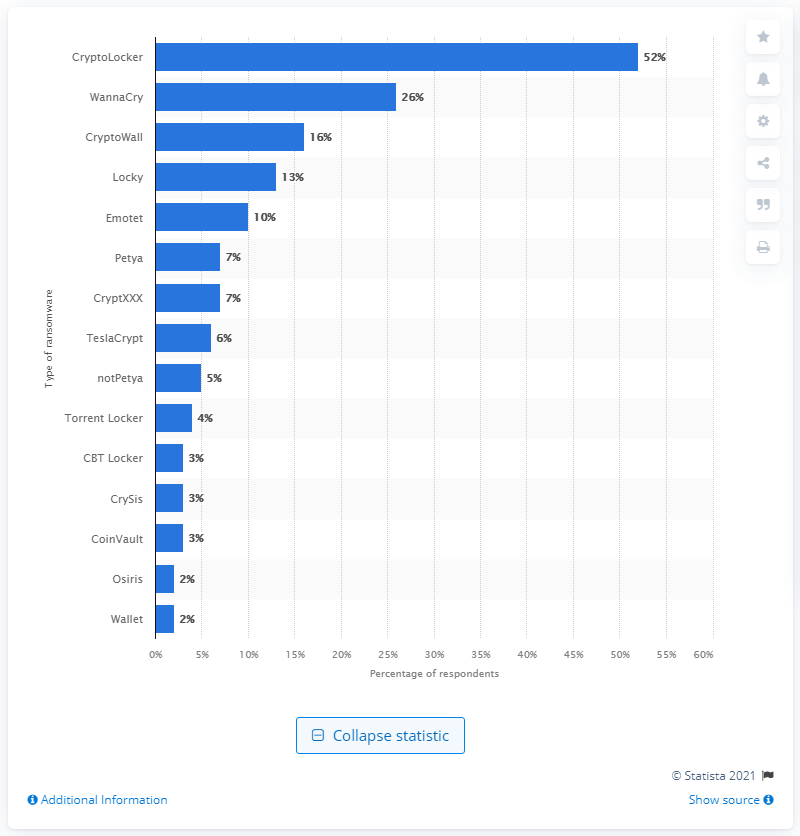Give some essential details in this illustration. According to a survey of MSPs, 26% reported that their clients had been affected by the WannaCry ransomware attack. 